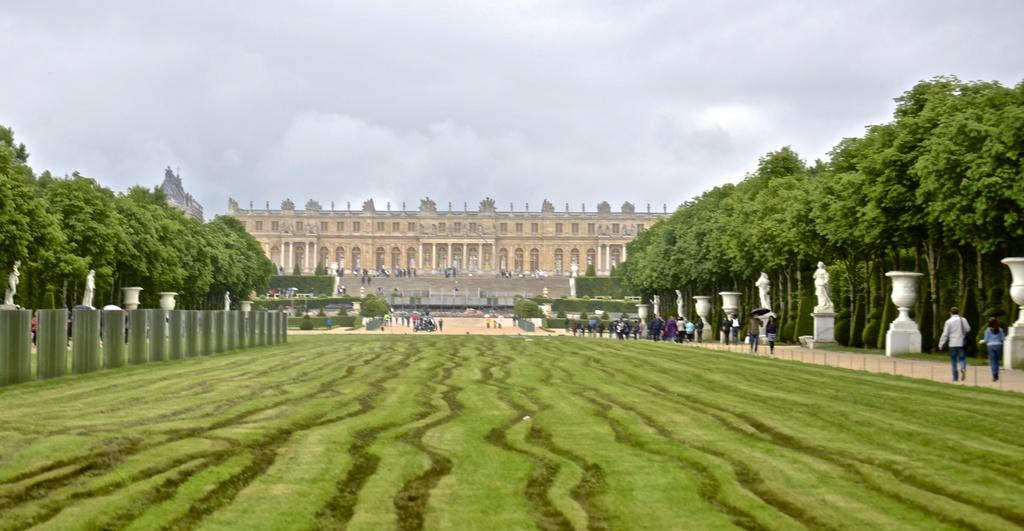How many persons can be seen in the image? There are persons in the image, but the exact number is not specified. What other objects or structures are present in the image? There are sculptures in the image. What type of natural elements can be seen in the image? There are trees in the image. What is the main architectural feature in the image? There is a building in the middle of the image. What is visible in the background of the image? There is a sky visible in the background of the image. What type of potato is being used to cry in the image? There is no potato or crying depicted in the image. What store is located near the building in the image? The facts provided do not mention any store in the image. 